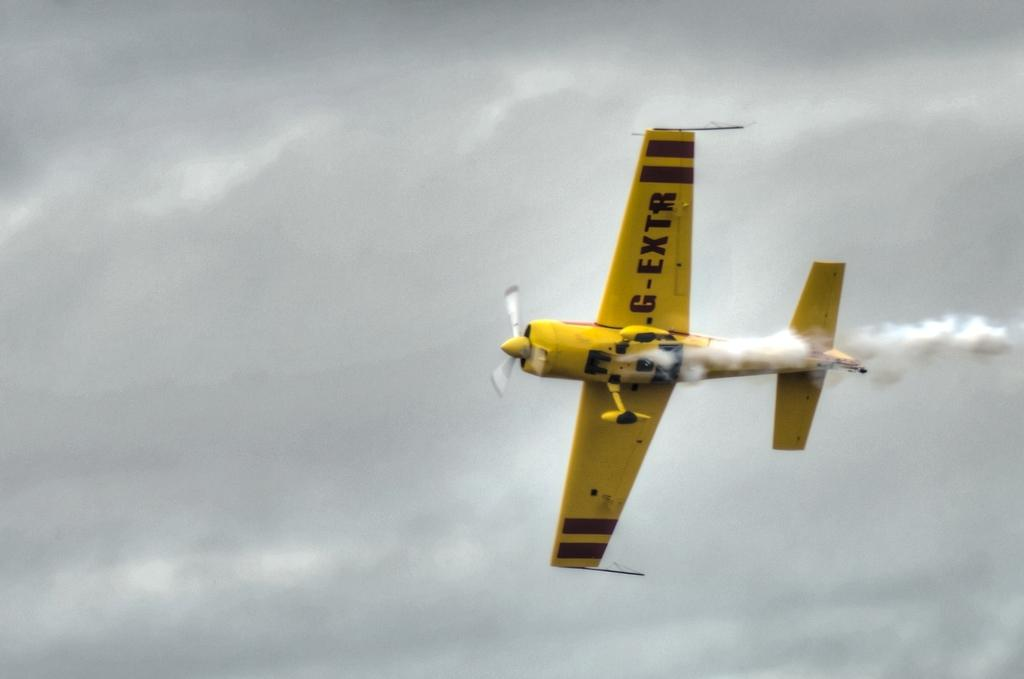<image>
Create a compact narrative representing the image presented. A yellow plane with the letters G-EXTR printed on the wing. 